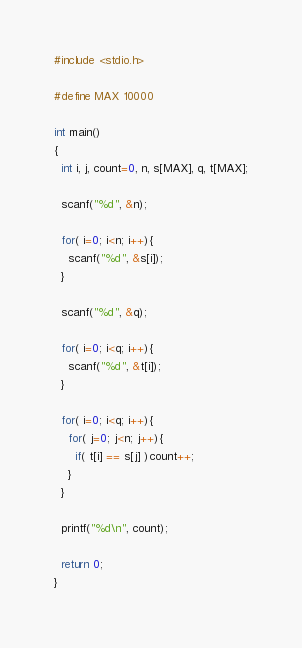Convert code to text. <code><loc_0><loc_0><loc_500><loc_500><_C_>#include <stdio.h>

#define MAX 10000

int main()
{
  int i, j, count=0, n, s[MAX], q, t[MAX];

  scanf("%d", &n);

  for( i=0; i<n; i++){
    scanf("%d", &s[i]);
  }

  scanf("%d", &q);

  for( i=0; i<q; i++){
    scanf("%d", &t[i]);
  }

  for( i=0; i<q; i++){
    for( j=0; j<n; j++){
      if( t[i] == s[j] )count++;
    }
  }

  printf("%d\n", count);

  return 0;
}</code> 